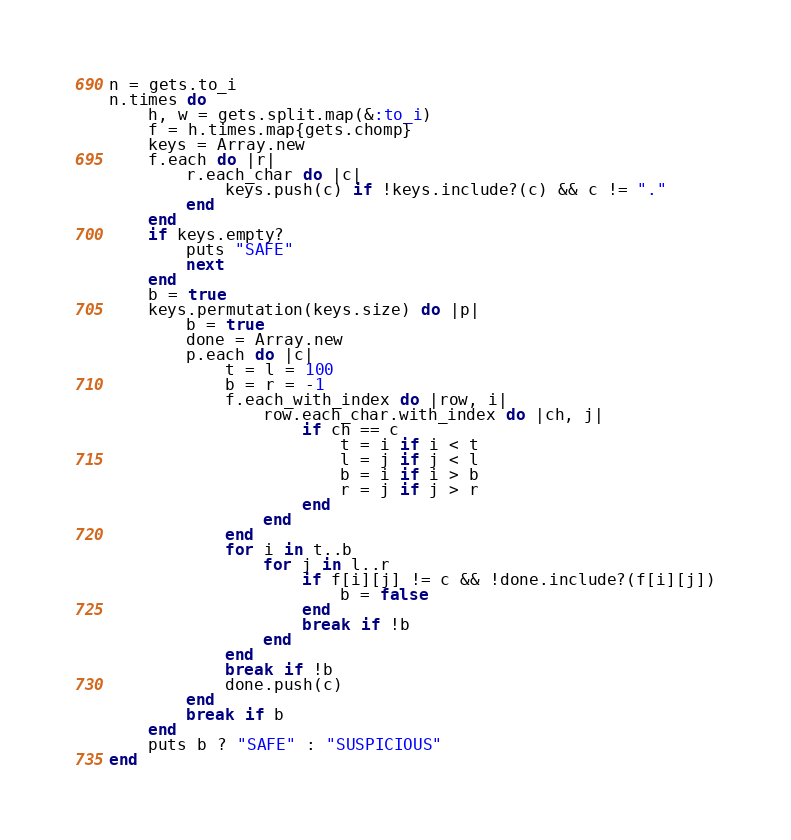<code> <loc_0><loc_0><loc_500><loc_500><_Ruby_>n = gets.to_i
n.times do
    h, w = gets.split.map(&:to_i)
    f = h.times.map{gets.chomp}
    keys = Array.new
    f.each do |r|
        r.each_char do |c|
            keys.push(c) if !keys.include?(c) && c != "."
        end
    end
    if keys.empty?
        puts "SAFE"
        next
    end
    b = true
    keys.permutation(keys.size) do |p|
        b = true
        done = Array.new
        p.each do |c|
            t = l = 100
            b = r = -1
            f.each_with_index do |row, i|
                row.each_char.with_index do |ch, j|
                    if ch == c
                        t = i if i < t
                        l = j if j < l
                        b = i if i > b
                        r = j if j > r
                    end
                end
            end
            for i in t..b
                for j in l..r
                    if f[i][j] != c && !done.include?(f[i][j])
                        b = false
                    end
                    break if !b
                end
            end
            break if !b
            done.push(c)
        end
        break if b
    end
    puts b ? "SAFE" : "SUSPICIOUS"
end</code> 